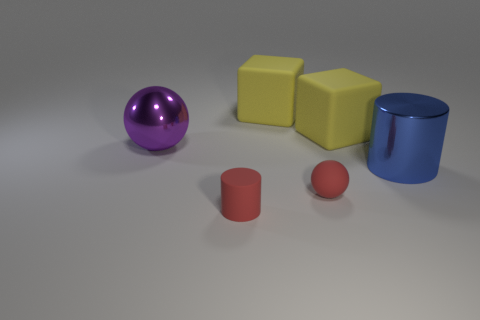Subtract 1 spheres. How many spheres are left? 1 Subtract all spheres. How many objects are left? 4 Subtract all red balls. How many green cylinders are left? 0 Subtract all red matte balls. Subtract all big things. How many objects are left? 1 Add 1 yellow rubber blocks. How many yellow rubber blocks are left? 3 Add 3 small spheres. How many small spheres exist? 4 Add 2 tiny purple metallic cylinders. How many objects exist? 8 Subtract 0 gray spheres. How many objects are left? 6 Subtract all purple blocks. Subtract all purple balls. How many blocks are left? 2 